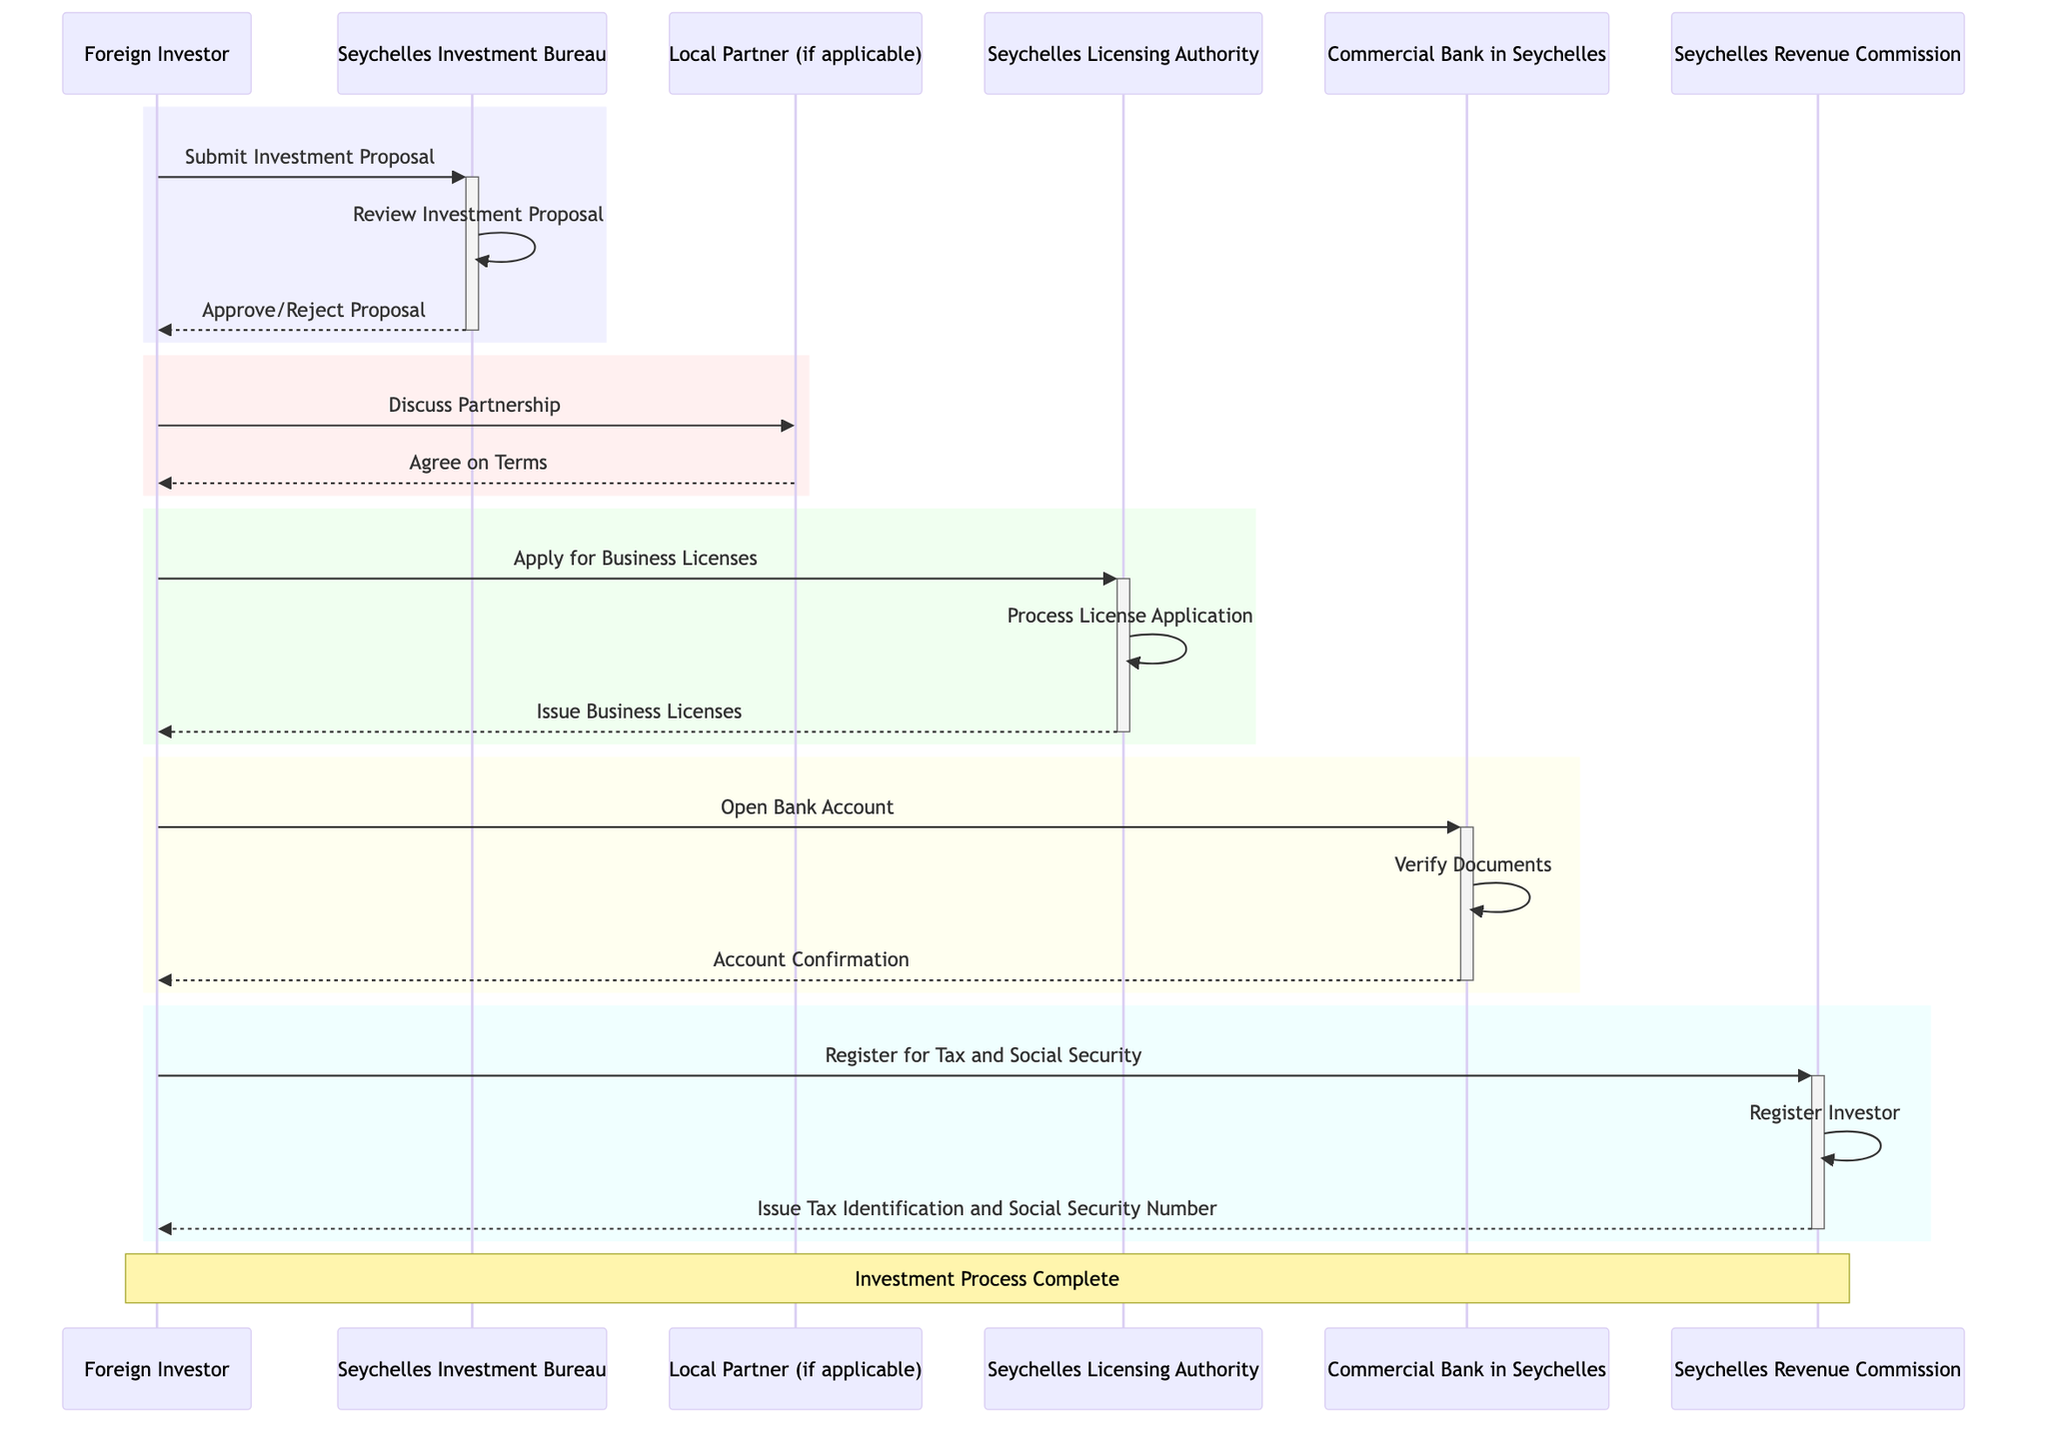What is the first action taken by the Foreign Investor? The diagram shows that the first action taken by the Foreign Investor is to submit an investment proposal to the Seychelles Investment Bureau.
Answer: Submit Investment Proposal How many actors are involved in the process? By examining the diagram, we can see that there are six actors involved: Foreign Investor, Seychelles Investment Bureau, Seychelles Licensing Authority, Commercial Bank in Seychelles, Seychelles Revenue Commission, and Local Partner (if applicable).
Answer: 6 What does the Seychelles Investment Bureau do after receiving the investment proposal? After receiving the investment proposal, the Seychelles Investment Bureau reviews it as indicated in the diagram.
Answer: Review Investment Proposal What is the relationship between the Seychelles Licensing Authority and the Business Licenses? The Seychelles Licensing Authority processes the license application and issues business licenses, showing that it acts as the authority responsible for licensing in the investment process.
Answer: Process License Application Which actor is responsible for document verification when opening a bank account? The actor responsible for document verification when opening a bank account is the Commercial Bank in Seychelles, as shown in the corresponding section of the diagram.
Answer: Commercial Bank in Seychelles What must the Foreign Investor do after receiving approval from the Seychelles Investment Bureau? After receiving approval, the Foreign Investor must discuss partnership terms with a local partner if applicable, indicating a necessary next step in the process.
Answer: Discuss Partnership How is the issuance of the Tax Identification and Social Security Number initiated? This issuance is initiated when the Foreign Investor registers for tax and social security with the Seychelles Revenue Commission, completing that part of the process.
Answer: Register for Tax and Social Security What is the last action that concludes the investment process? The last action that concludes the investment process is the issuance of the tax identification and social security number by the Seychelles Revenue Commission, which signifies completion.
Answer: Issue Tax Identification and Social Security Number 